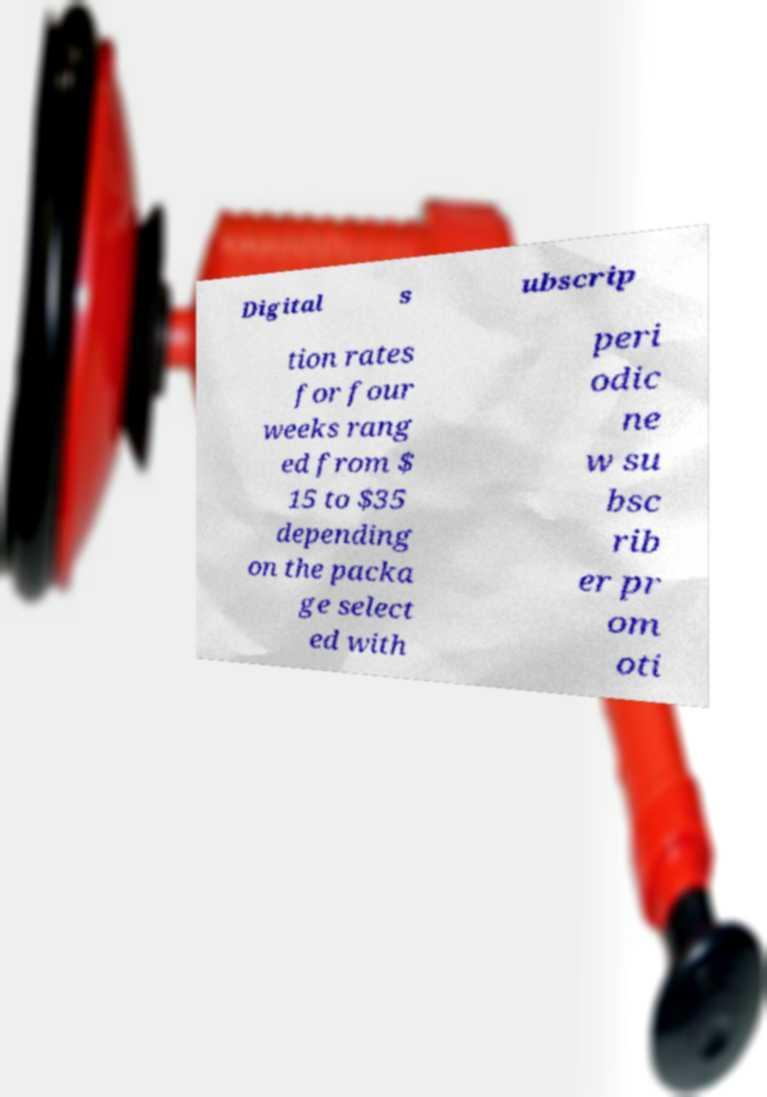Could you assist in decoding the text presented in this image and type it out clearly? Digital s ubscrip tion rates for four weeks rang ed from $ 15 to $35 depending on the packa ge select ed with peri odic ne w su bsc rib er pr om oti 